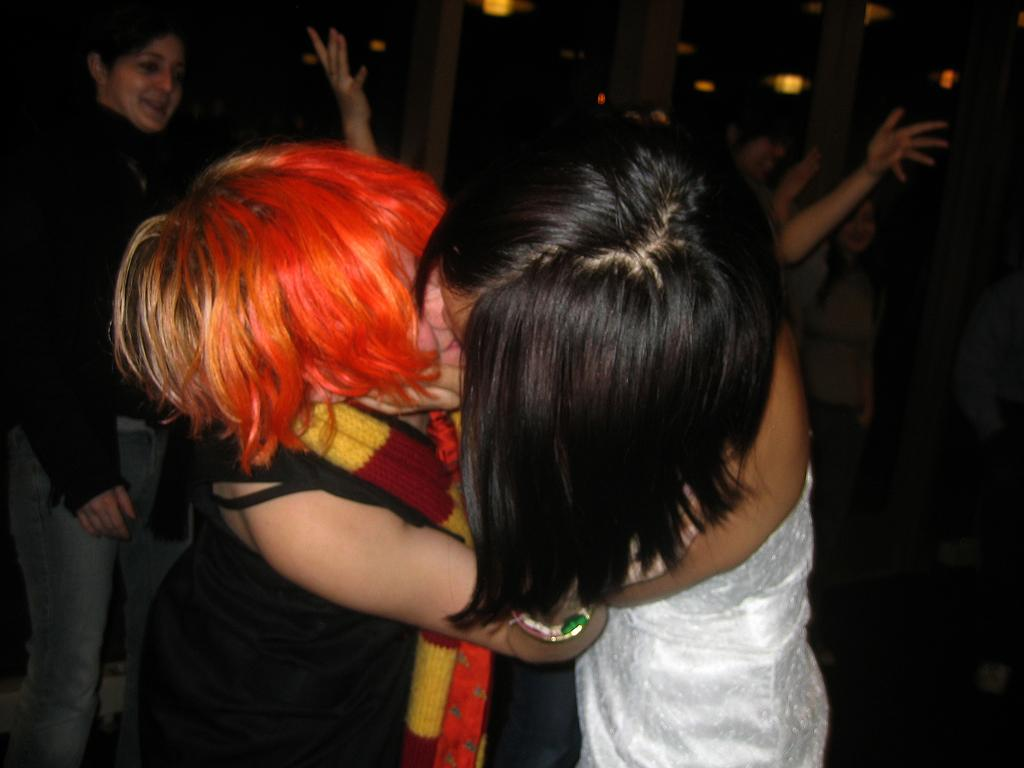What is the primary subject of the image? The primary subject of the image is women standing. Can you describe the background of the image? There is a glass window in the background of the image. What type of care can be seen being provided to the women in the image? There is no indication in the image that the women are receiving any care, as the image only shows them standing. 